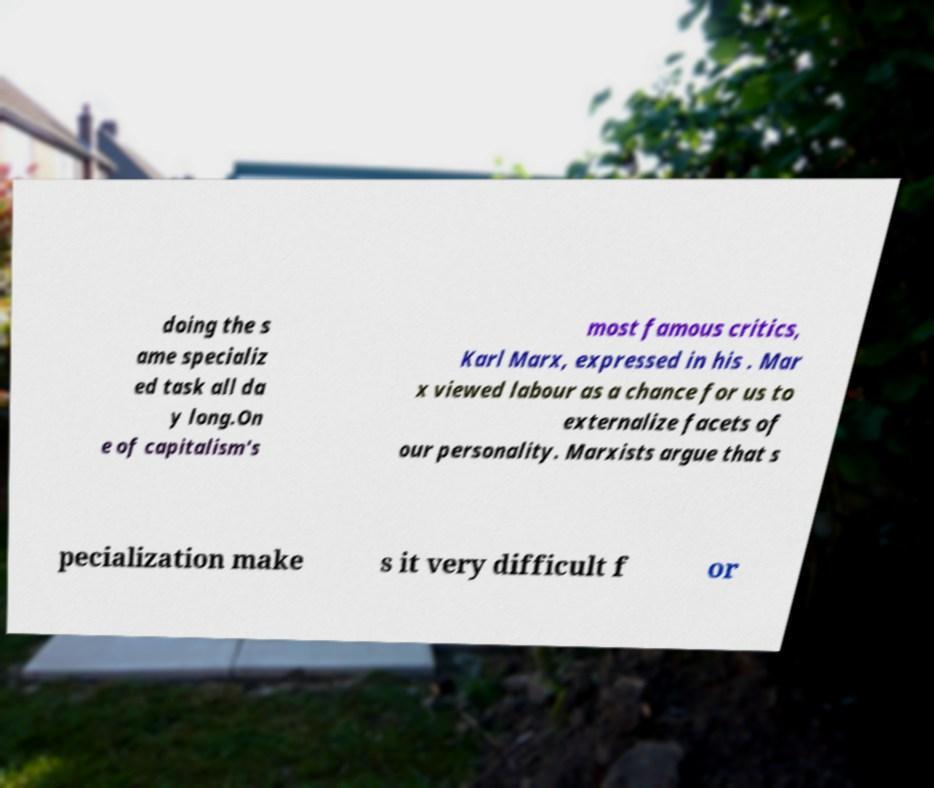What messages or text are displayed in this image? I need them in a readable, typed format. doing the s ame specializ ed task all da y long.On e of capitalism's most famous critics, Karl Marx, expressed in his . Mar x viewed labour as a chance for us to externalize facets of our personality. Marxists argue that s pecialization make s it very difficult f or 